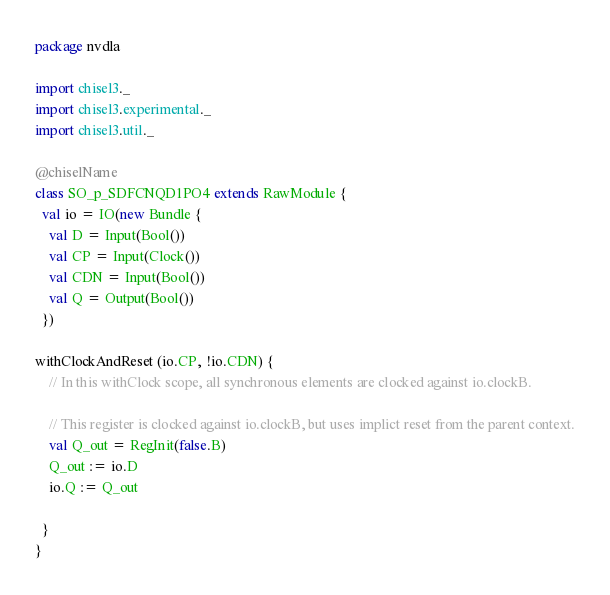Convert code to text. <code><loc_0><loc_0><loc_500><loc_500><_Scala_>package nvdla

import chisel3._
import chisel3.experimental._
import chisel3.util._

@chiselName
class SO_p_SDFCNQD1PO4 extends RawModule {
  val io = IO(new Bundle {
    val D = Input(Bool())
    val CP = Input(Clock())
    val CDN = Input(Bool())
    val Q = Output(Bool())
  })

withClockAndReset (io.CP, !io.CDN) {
    // In this withClock scope, all synchronous elements are clocked against io.clockB.

    // This register is clocked against io.clockB, but uses implict reset from the parent context.
    val Q_out = RegInit(false.B)
    Q_out := io.D
    io.Q := Q_out
    
  }
}



</code> 